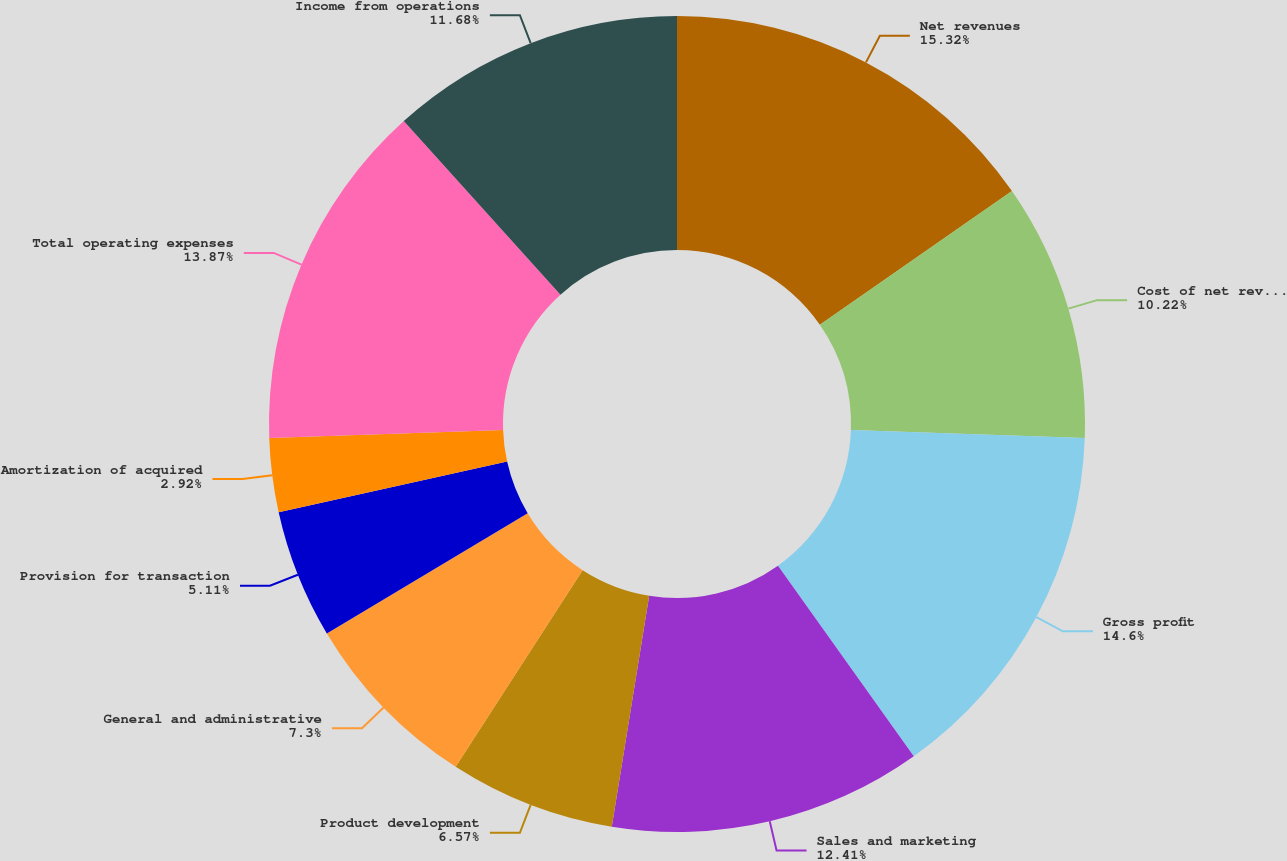<chart> <loc_0><loc_0><loc_500><loc_500><pie_chart><fcel>Net revenues<fcel>Cost of net revenues<fcel>Gross profit<fcel>Sales and marketing<fcel>Product development<fcel>General and administrative<fcel>Provision for transaction<fcel>Amortization of acquired<fcel>Total operating expenses<fcel>Income from operations<nl><fcel>15.33%<fcel>10.22%<fcel>14.6%<fcel>12.41%<fcel>6.57%<fcel>7.3%<fcel>5.11%<fcel>2.92%<fcel>13.87%<fcel>11.68%<nl></chart> 